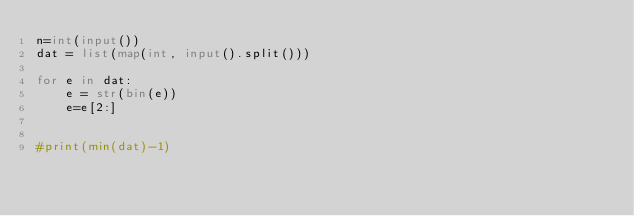<code> <loc_0><loc_0><loc_500><loc_500><_Python_>n=int(input())
dat = list(map(int, input().split()))

for e in dat:
    e = str(bin(e))
    e=e[2:]
       

#print(min(dat)-1)

</code> 